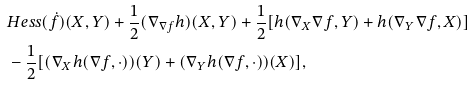<formula> <loc_0><loc_0><loc_500><loc_500>& H e s s ( \dot { f } ) ( X , Y ) + \frac { 1 } { 2 } ( \nabla _ { \nabla f } h ) ( X , Y ) + \frac { 1 } { 2 } [ h ( \nabla _ { X } \nabla f , Y ) + h ( \nabla _ { Y } \nabla f , X ) ] \\ & - \frac { 1 } { 2 } [ ( \nabla _ { X } h ( \nabla f , \cdot ) ) ( Y ) + ( \nabla _ { Y } h ( \nabla f , \cdot ) ) ( X ) ] ,</formula> 